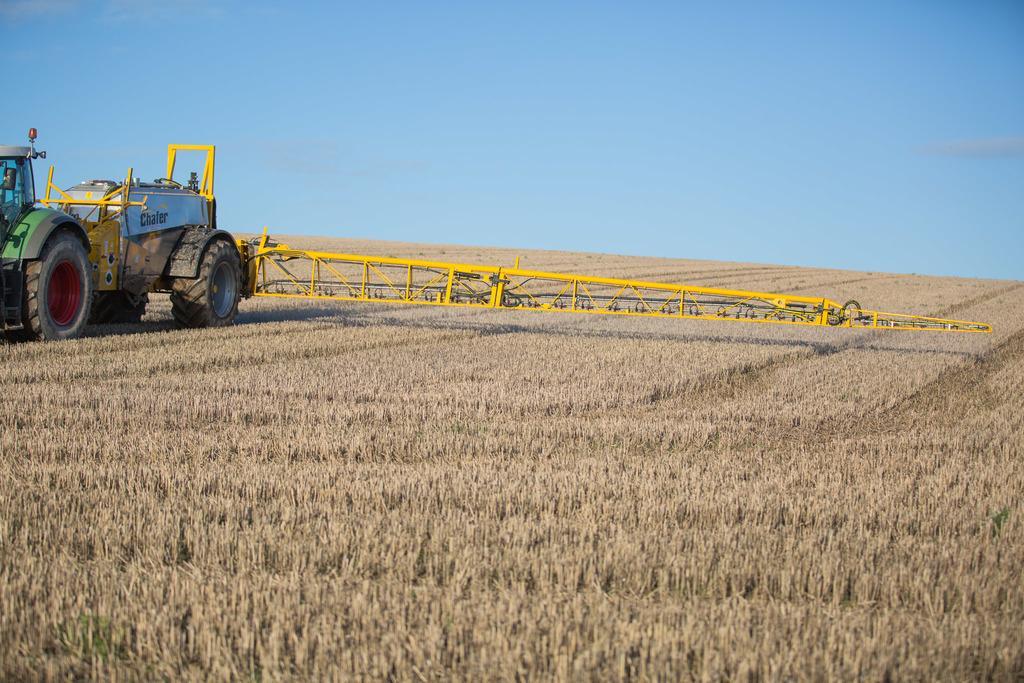How would you summarize this image in a sentence or two? In the picture I can see a tractor on the left side of the image. Here we can see the dry grass, we can see a yellow color object and the plain blue color sky in the background. 